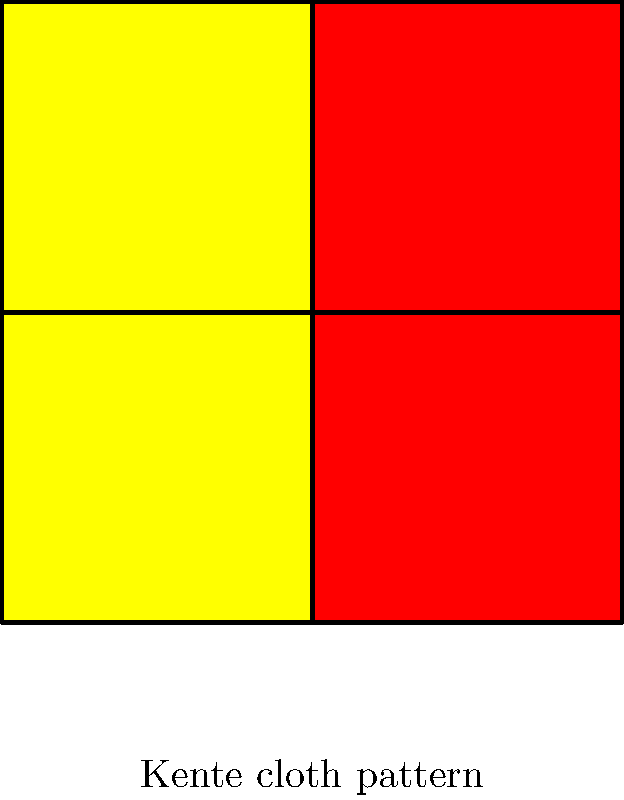The image above shows a simplified representation of a Kente cloth pattern, a traditional West African textile. Consider the symmetry group of this pattern. Which of the following transformations is NOT an element of this group?

A) 90-degree rotation
B) 180-degree rotation
C) Horizontal reflection
D) Vertical reflection To answer this question, we need to analyze the symmetries of the given Kente cloth pattern:

1. 90-degree rotation: If we rotate the pattern 90 degrees clockwise or counterclockwise, we get a different arrangement. This is not a symmetry of the pattern.

2. 180-degree rotation: If we rotate the pattern 180 degrees, we get the same arrangement. This is a symmetry of the pattern.

3. Horizontal reflection: If we reflect the pattern horizontally (across a horizontal line through the center), we get the same arrangement. This is a symmetry of the pattern.

4. Vertical reflection: If we reflect the pattern vertically (across a vertical line through the center), we get the same arrangement. This is a symmetry of the pattern.

5. Identity: Keeping the pattern as is (no transformation) is always a symmetry.

The symmetry group of this pattern is the Klein four-group, $V_4$, which consists of:
- Identity
- 180-degree rotation
- Horizontal reflection
- Vertical reflection

Therefore, the 90-degree rotation is the only transformation listed that is not an element of the symmetry group of this Kente cloth pattern.

It's important to note that while this simplified representation has these symmetries, actual Kente cloth patterns are often more complex and may have different symmetry groups. The cultural significance of Kente cloth lies in its intricate designs and colors, which often convey specific messages or represent historical events in West African, particularly Ghanaian, culture.
Answer: A) 90-degree rotation 